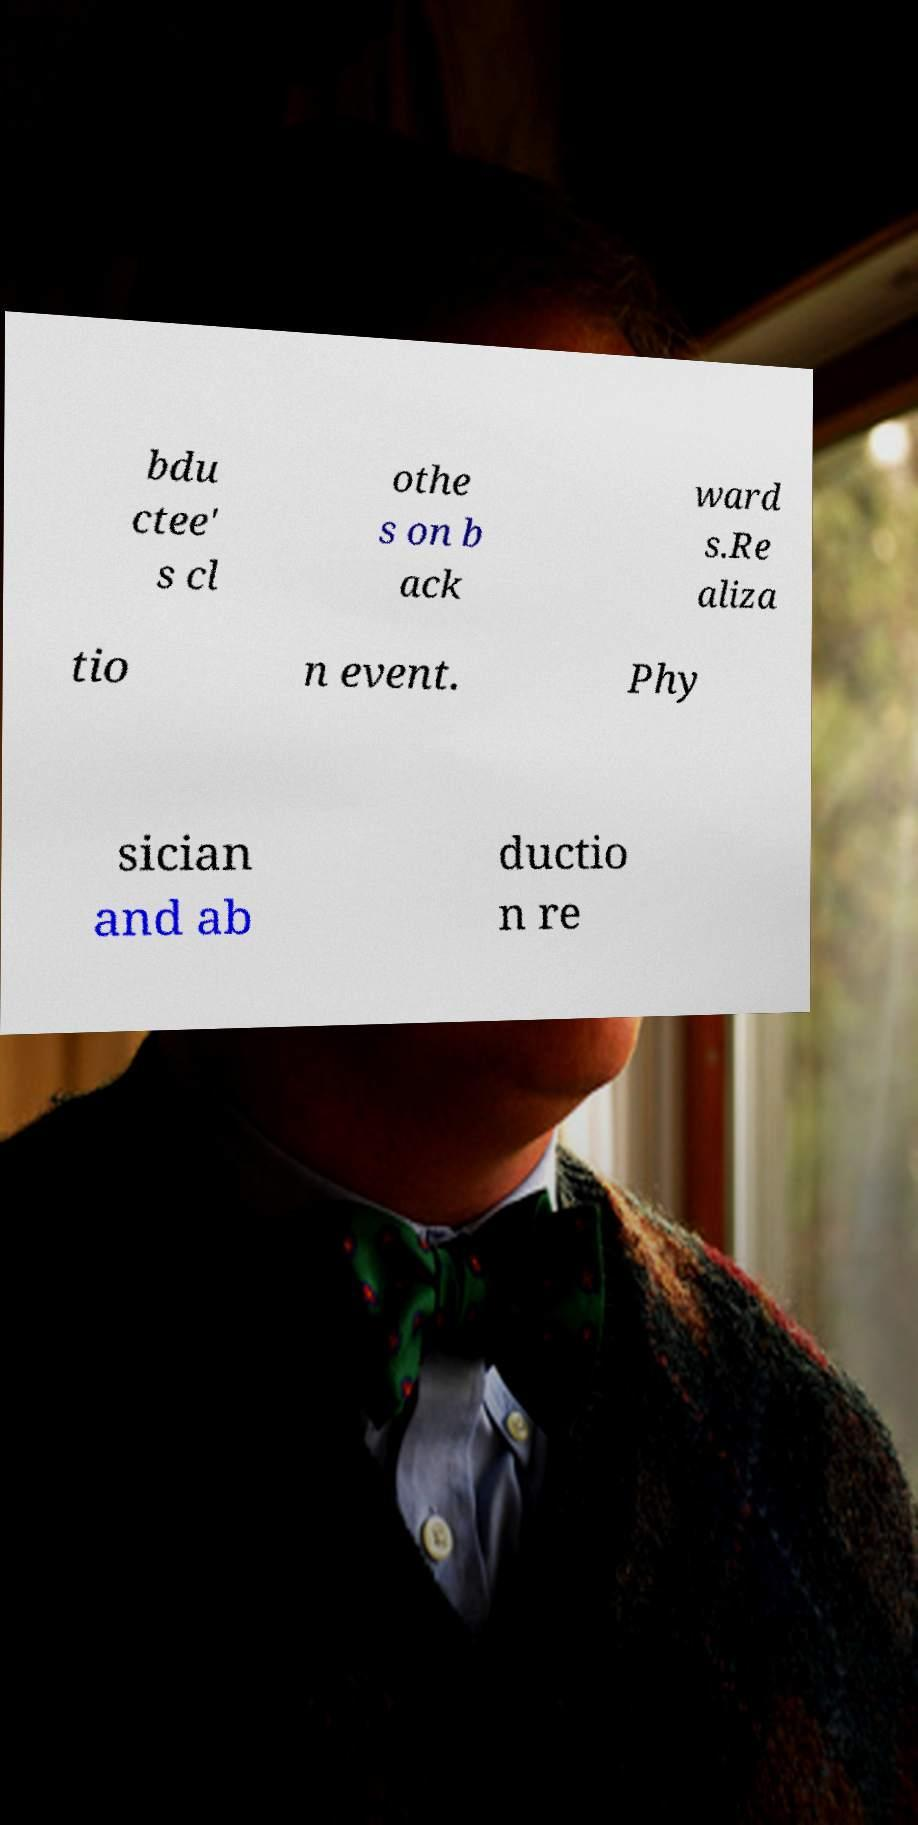Can you read and provide the text displayed in the image?This photo seems to have some interesting text. Can you extract and type it out for me? bdu ctee' s cl othe s on b ack ward s.Re aliza tio n event. Phy sician and ab ductio n re 